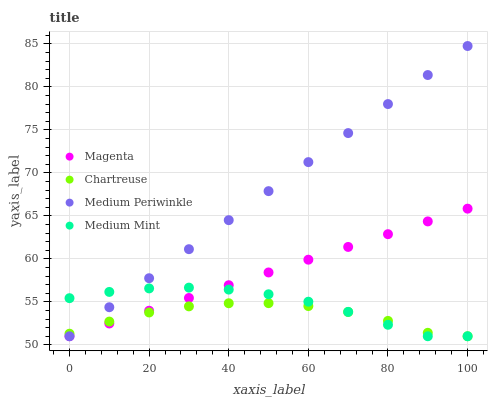Does Chartreuse have the minimum area under the curve?
Answer yes or no. Yes. Does Medium Periwinkle have the maximum area under the curve?
Answer yes or no. Yes. Does Magenta have the minimum area under the curve?
Answer yes or no. No. Does Magenta have the maximum area under the curve?
Answer yes or no. No. Is Magenta the smoothest?
Answer yes or no. Yes. Is Chartreuse the roughest?
Answer yes or no. Yes. Is Medium Periwinkle the smoothest?
Answer yes or no. No. Is Medium Periwinkle the roughest?
Answer yes or no. No. Does Medium Mint have the lowest value?
Answer yes or no. Yes. Does Medium Periwinkle have the highest value?
Answer yes or no. Yes. Does Magenta have the highest value?
Answer yes or no. No. Does Chartreuse intersect Medium Periwinkle?
Answer yes or no. Yes. Is Chartreuse less than Medium Periwinkle?
Answer yes or no. No. Is Chartreuse greater than Medium Periwinkle?
Answer yes or no. No. 